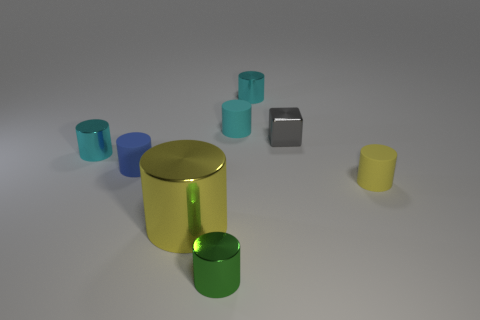There is a tiny metal cylinder in front of the tiny yellow rubber cylinder that is to the right of the big yellow thing that is in front of the small cyan matte object; what color is it?
Offer a terse response. Green. Are there any other things that are the same color as the cube?
Ensure brevity in your answer.  No. Does the gray thing have the same size as the green metal cylinder?
Your answer should be very brief. Yes. How many objects are either small things to the right of the blue thing or cylinders behind the yellow rubber cylinder?
Your answer should be very brief. 7. There is a cyan object that is on the left side of the yellow thing to the left of the shiny block; what is its material?
Make the answer very short. Metal. How many other objects are the same material as the block?
Your answer should be very brief. 4. Does the tiny yellow rubber thing have the same shape as the tiny blue matte object?
Provide a short and direct response. Yes. What size is the object on the right side of the tiny gray object?
Offer a very short reply. Small. There is a blue matte thing; is it the same size as the cyan shiny cylinder to the left of the blue cylinder?
Provide a short and direct response. Yes. Are there fewer green metal things in front of the small blue rubber object than cyan metal things?
Offer a very short reply. Yes. 